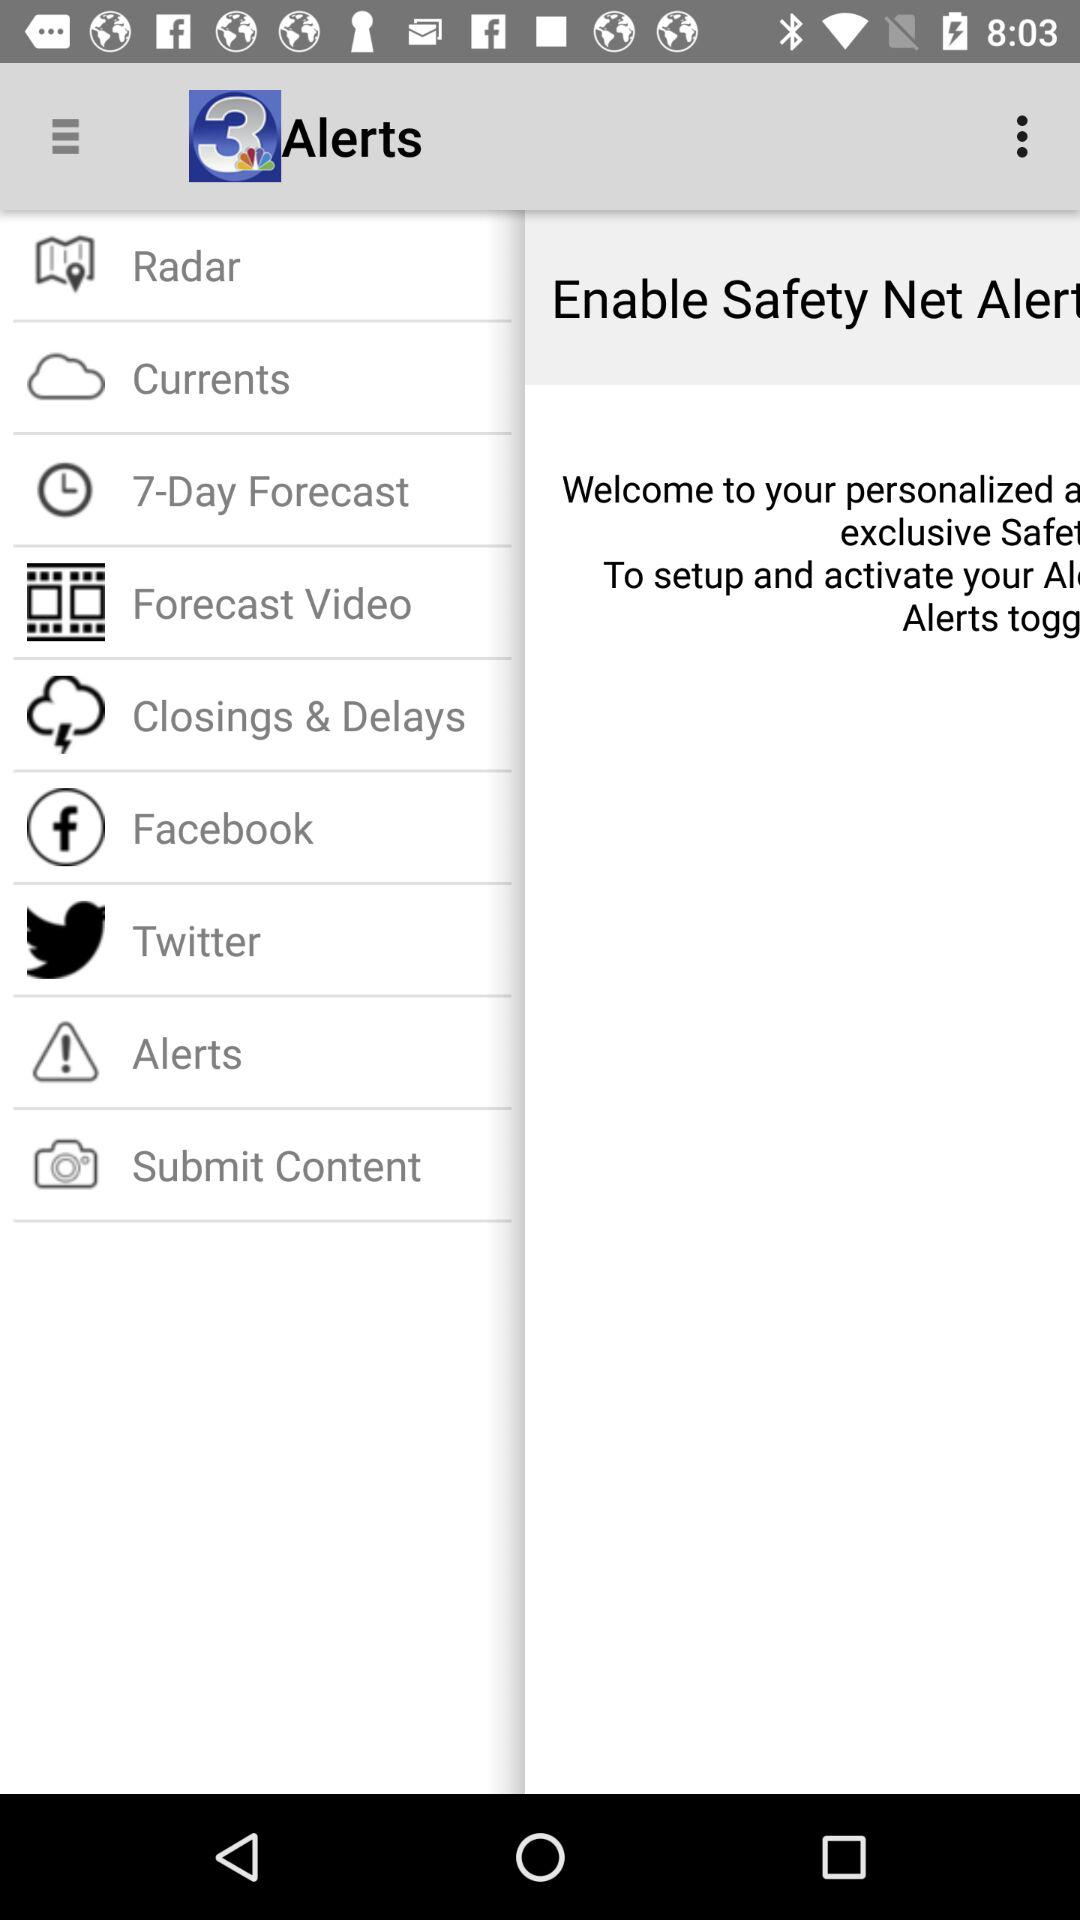What is the name of the application? The name of the application is "News3LV KSNV Las Vegas News". 